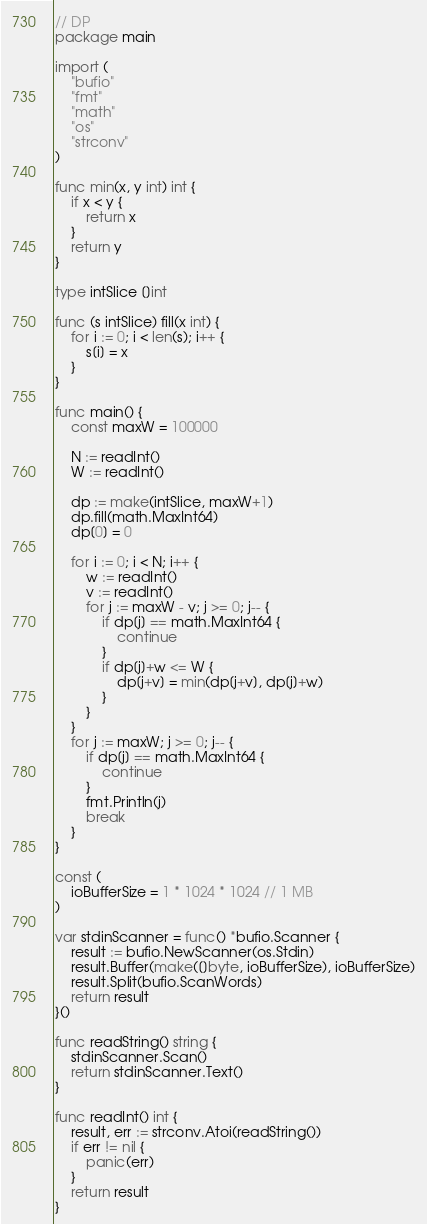<code> <loc_0><loc_0><loc_500><loc_500><_Go_>// DP
package main

import (
	"bufio"
	"fmt"
	"math"
	"os"
	"strconv"
)

func min(x, y int) int {
	if x < y {
		return x
	}
	return y
}

type intSlice []int

func (s intSlice) fill(x int) {
	for i := 0; i < len(s); i++ {
		s[i] = x
	}
}

func main() {
	const maxW = 100000

	N := readInt()
	W := readInt()

	dp := make(intSlice, maxW+1)
	dp.fill(math.MaxInt64)
	dp[0] = 0

	for i := 0; i < N; i++ {
		w := readInt()
		v := readInt()
		for j := maxW - v; j >= 0; j-- {
			if dp[j] == math.MaxInt64 {
				continue
			}
			if dp[j]+w <= W {
				dp[j+v] = min(dp[j+v], dp[j]+w)
			}
		}
	}
	for j := maxW; j >= 0; j-- {
		if dp[j] == math.MaxInt64 {
			continue
		}
		fmt.Println(j)
		break
	}
}

const (
	ioBufferSize = 1 * 1024 * 1024 // 1 MB
)

var stdinScanner = func() *bufio.Scanner {
	result := bufio.NewScanner(os.Stdin)
	result.Buffer(make([]byte, ioBufferSize), ioBufferSize)
	result.Split(bufio.ScanWords)
	return result
}()

func readString() string {
	stdinScanner.Scan()
	return stdinScanner.Text()
}

func readInt() int {
	result, err := strconv.Atoi(readString())
	if err != nil {
		panic(err)
	}
	return result
}
</code> 